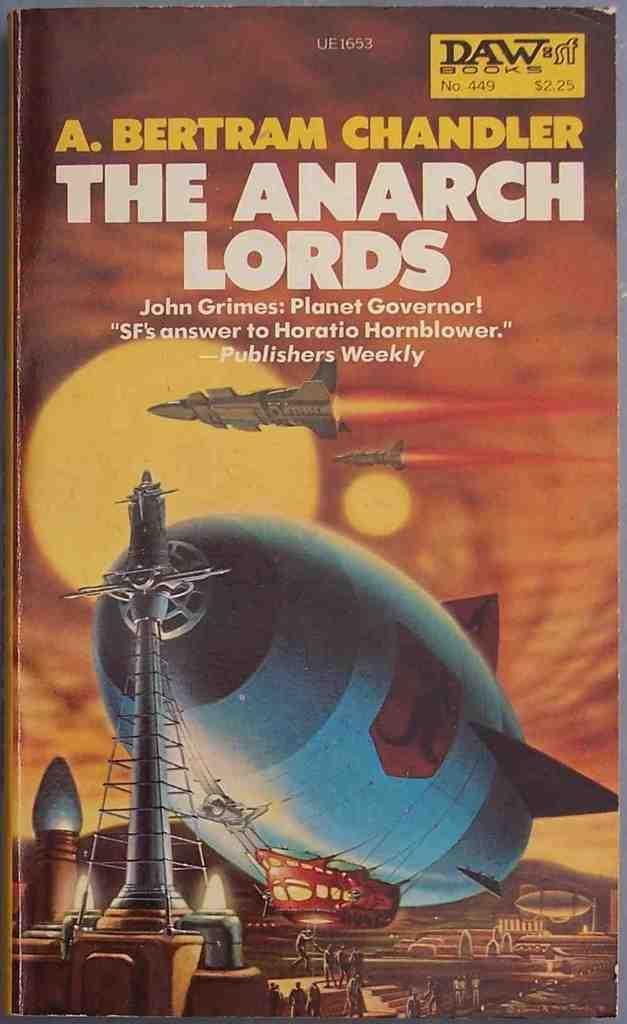<image>
Describe the image concisely. A book called The Anarch Lords shows a huge blimp on the cover. 